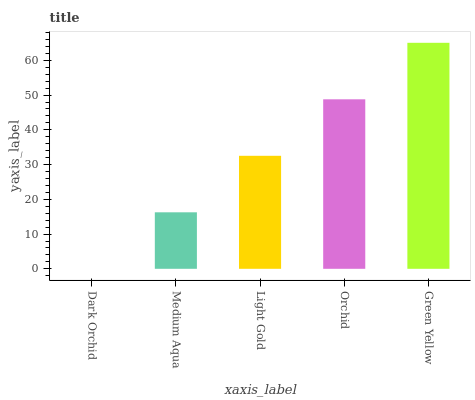Is Dark Orchid the minimum?
Answer yes or no. Yes. Is Green Yellow the maximum?
Answer yes or no. Yes. Is Medium Aqua the minimum?
Answer yes or no. No. Is Medium Aqua the maximum?
Answer yes or no. No. Is Medium Aqua greater than Dark Orchid?
Answer yes or no. Yes. Is Dark Orchid less than Medium Aqua?
Answer yes or no. Yes. Is Dark Orchid greater than Medium Aqua?
Answer yes or no. No. Is Medium Aqua less than Dark Orchid?
Answer yes or no. No. Is Light Gold the high median?
Answer yes or no. Yes. Is Light Gold the low median?
Answer yes or no. Yes. Is Orchid the high median?
Answer yes or no. No. Is Medium Aqua the low median?
Answer yes or no. No. 